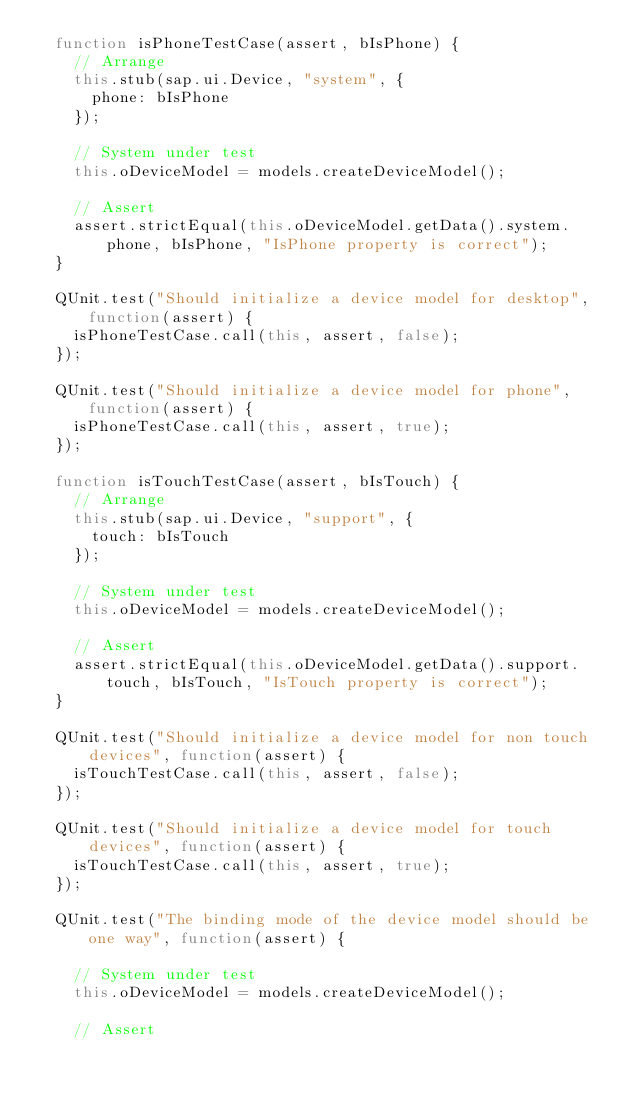Convert code to text. <code><loc_0><loc_0><loc_500><loc_500><_JavaScript_>	function isPhoneTestCase(assert, bIsPhone) {
		// Arrange
		this.stub(sap.ui.Device, "system", {
			phone: bIsPhone
		});

		// System under test
		this.oDeviceModel = models.createDeviceModel();

		// Assert
		assert.strictEqual(this.oDeviceModel.getData().system.phone, bIsPhone, "IsPhone property is correct");
	}

	QUnit.test("Should initialize a device model for desktop", function(assert) {
		isPhoneTestCase.call(this, assert, false);
	});

	QUnit.test("Should initialize a device model for phone", function(assert) {
		isPhoneTestCase.call(this, assert, true);
	});

	function isTouchTestCase(assert, bIsTouch) {
		// Arrange
		this.stub(sap.ui.Device, "support", {
			touch: bIsTouch
		});

		// System under test
		this.oDeviceModel = models.createDeviceModel();

		// Assert
		assert.strictEqual(this.oDeviceModel.getData().support.touch, bIsTouch, "IsTouch property is correct");
	}

	QUnit.test("Should initialize a device model for non touch devices", function(assert) {
		isTouchTestCase.call(this, assert, false);
	});

	QUnit.test("Should initialize a device model for touch devices", function(assert) {
		isTouchTestCase.call(this, assert, true);
	});

	QUnit.test("The binding mode of the device model should be one way", function(assert) {

		// System under test
		this.oDeviceModel = models.createDeviceModel();

		// Assert</code> 